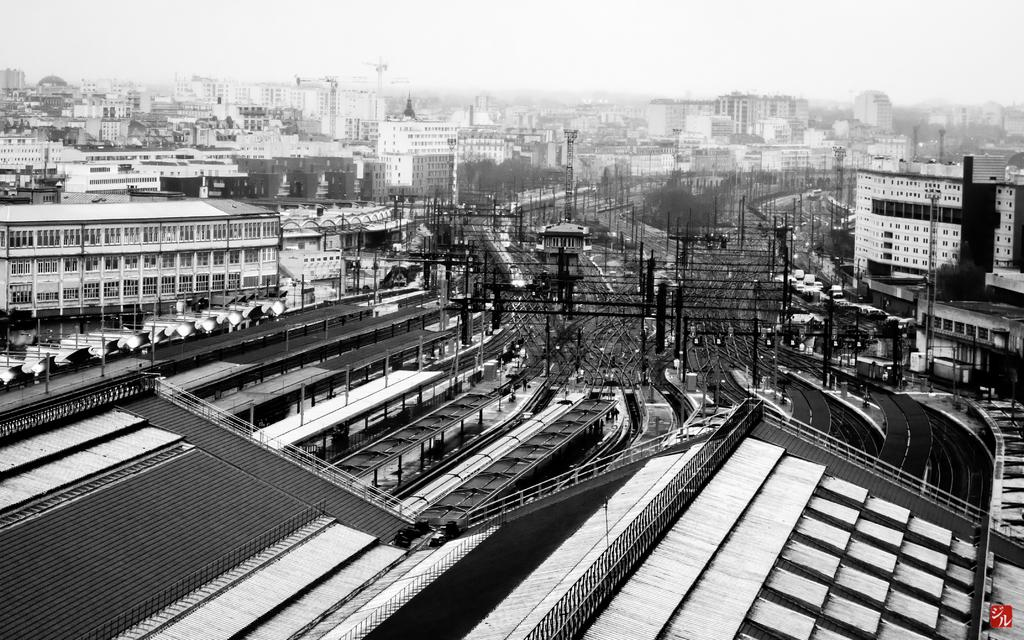What is the color scheme of the image? The image is black and white. What can be seen running through the image? There are railway tracks in the image. What type of structures are present in the image? There are buildings in the image. What else can be seen in the image besides the railway tracks and buildings? There are electric poles in the image. How would you describe the background of the image? The background of the image is blurred. How many dolls are sitting on the electric poles in the image? There are no dolls present in the image, and therefore no dolls can be seen sitting on the electric poles. 